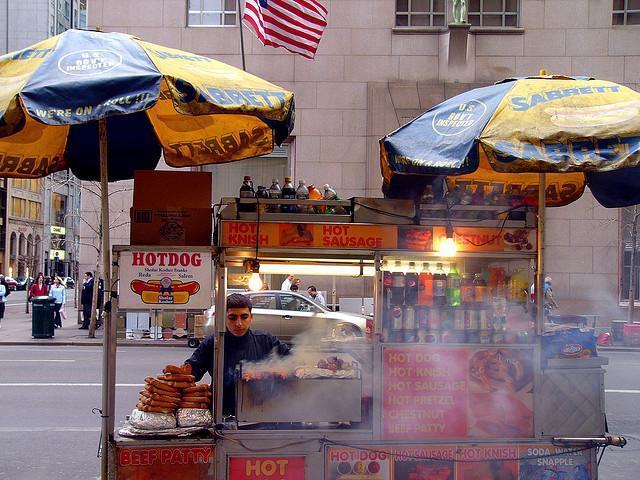How many umbrellas are there?
Give a very brief answer. 2. 